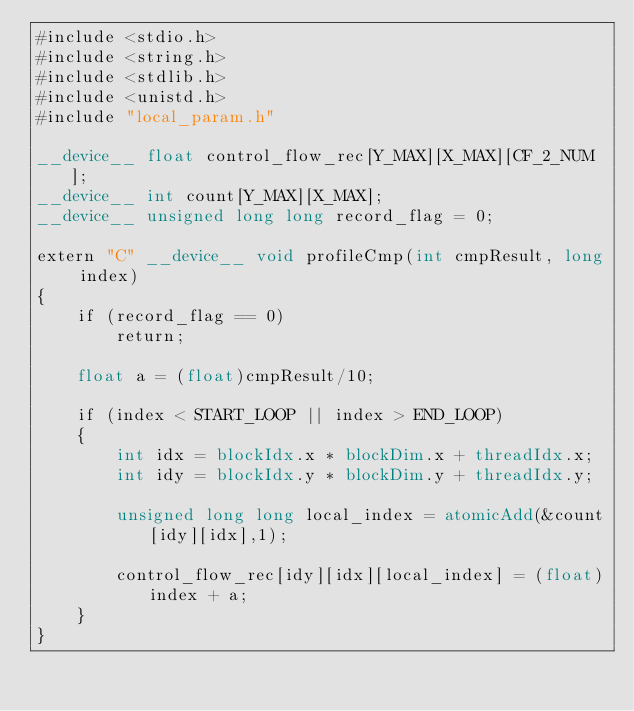<code> <loc_0><loc_0><loc_500><loc_500><_Cuda_>#include <stdio.h>
#include <string.h>
#include <stdlib.h>
#include <unistd.h>
#include "local_param.h"

__device__ float control_flow_rec[Y_MAX][X_MAX][CF_2_NUM];
__device__ int count[Y_MAX][X_MAX];
__device__ unsigned long long record_flag = 0;

extern "C" __device__ void profileCmp(int cmpResult, long index)
{
    if (record_flag == 0)
        return;

    float a = (float)cmpResult/10;
    
    if (index < START_LOOP || index > END_LOOP)
    {
        int idx = blockIdx.x * blockDim.x + threadIdx.x;  
        int idy = blockIdx.y * blockDim.y + threadIdx.y;

        unsigned long long local_index = atomicAdd(&count[idy][idx],1);

        control_flow_rec[idy][idx][local_index] = (float)index + a;
    }
}

</code> 